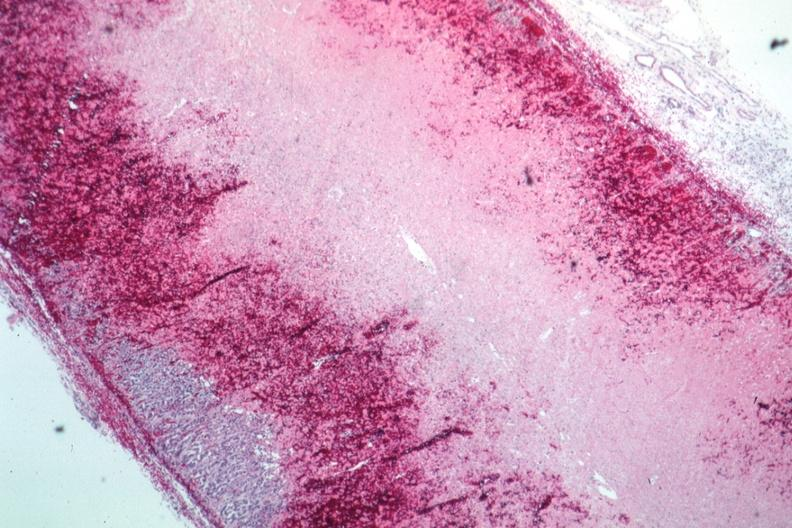what does this image show?
Answer the question using a single word or phrase. Infarction and hemorrhage well shown 